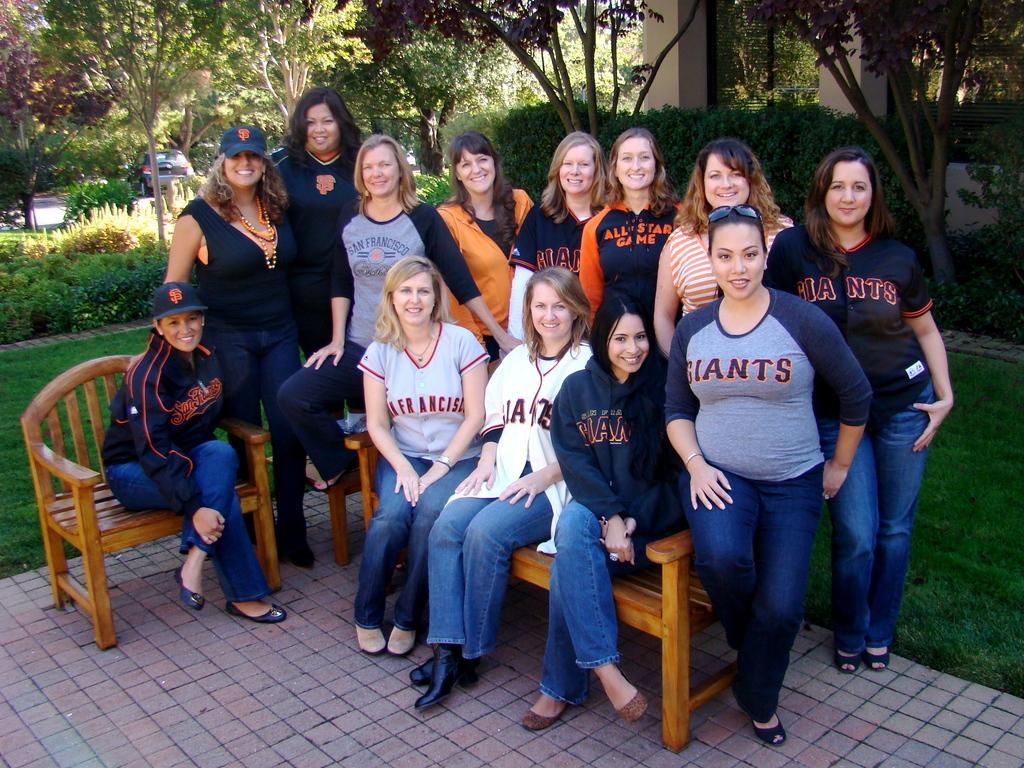Can you describe this image briefly? In this picture we can see some people standing and some people sitting, in the background there are some trees, plants and grass, on the right side there is a house, these people are smiling. 